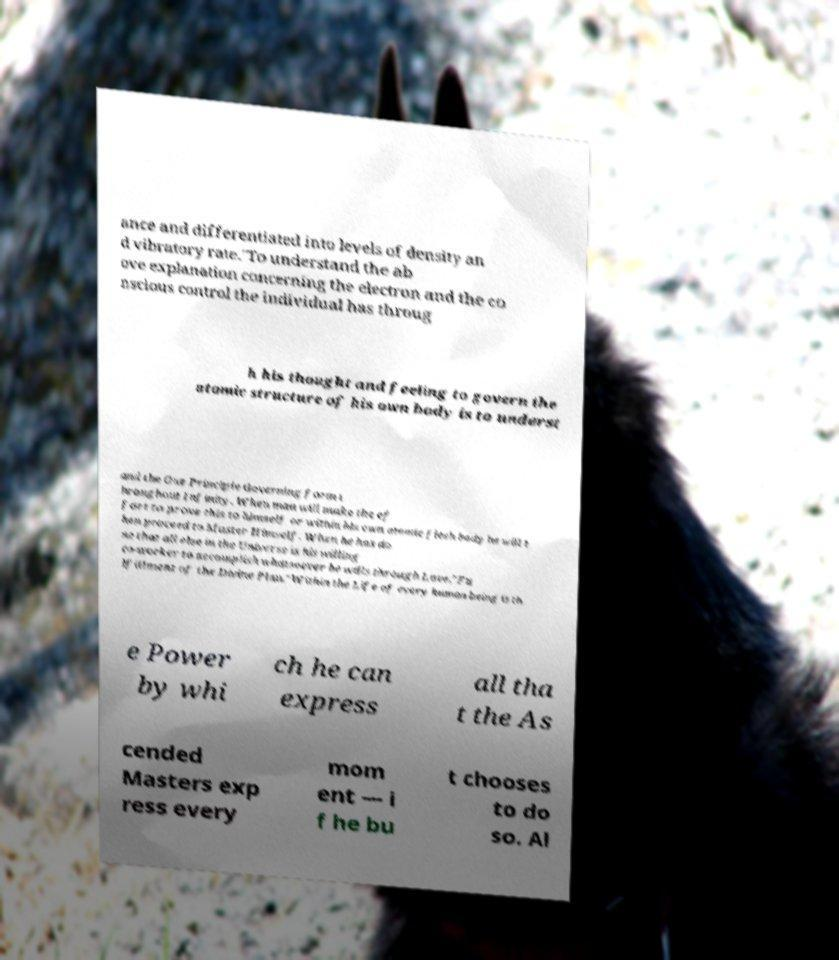There's text embedded in this image that I need extracted. Can you transcribe it verbatim? ance and differentiated into levels of density an d vibratory rate."To understand the ab ove explanation concerning the electron and the co nscious control the individual has throug h his thought and feeling to govern the atomic structure of his own body is to underst and the One Principle Governing form t hroughout Infinity. When man will make the ef fort to prove this to himself or within his own atomic flesh body he will t hen proceed to Master Himself. When he has do ne that all else in the Universe is his willing co-worker to accomplish whatsoever he wills through Love."Fu lfillment of the Divine Plan."Within the Life of every human being is th e Power by whi ch he can express all tha t the As cended Masters exp ress every mom ent — i f he bu t chooses to do so. Al 